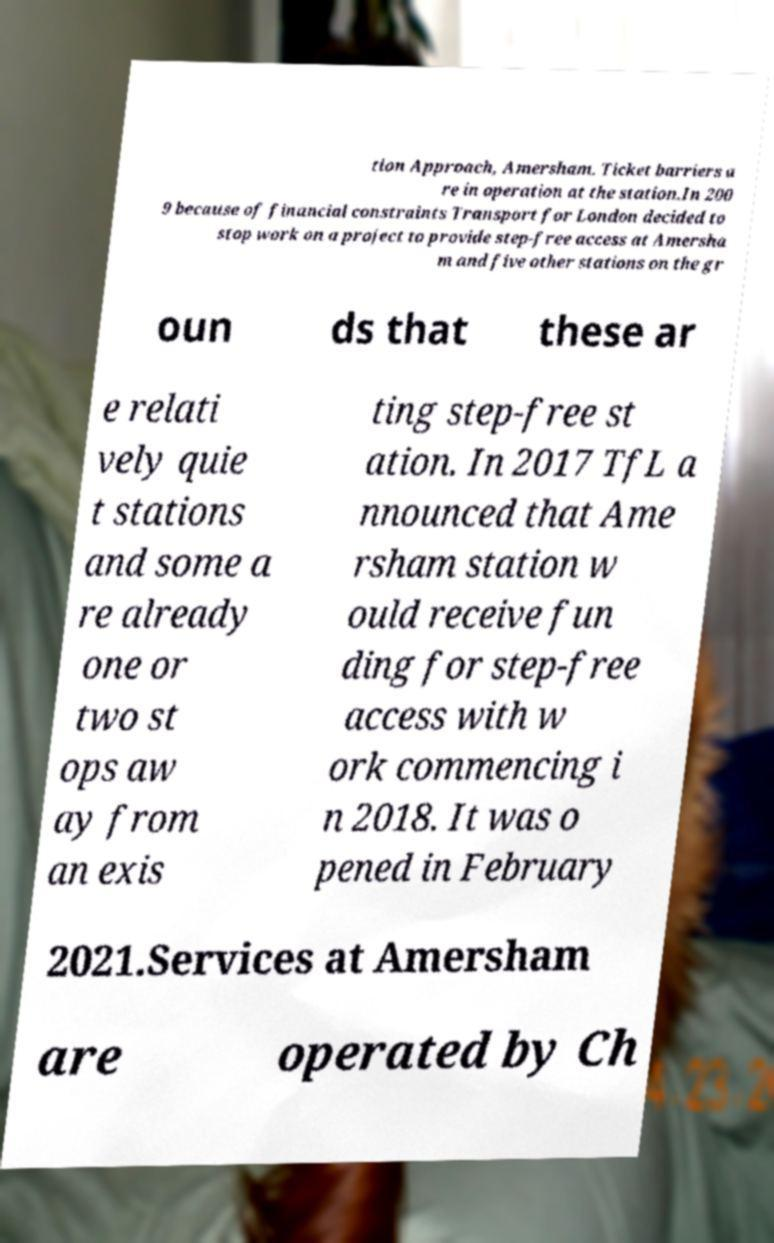There's text embedded in this image that I need extracted. Can you transcribe it verbatim? tion Approach, Amersham. Ticket barriers a re in operation at the station.In 200 9 because of financial constraints Transport for London decided to stop work on a project to provide step-free access at Amersha m and five other stations on the gr oun ds that these ar e relati vely quie t stations and some a re already one or two st ops aw ay from an exis ting step-free st ation. In 2017 TfL a nnounced that Ame rsham station w ould receive fun ding for step-free access with w ork commencing i n 2018. It was o pened in February 2021.Services at Amersham are operated by Ch 